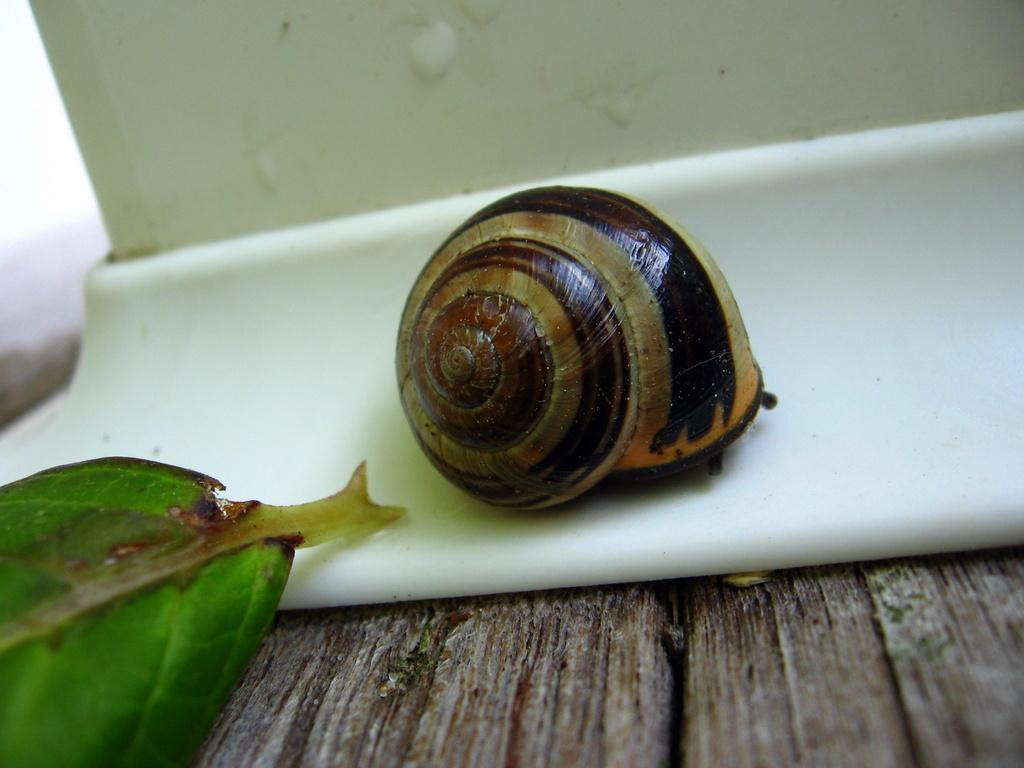What type of furniture is present in the image? There is a table in the image. What is located on the table? There is a snail and a leaf on the table. What type of peace agreement is being discussed at the meeting in the image? There is no meeting or peace agreement present in the image; it only features a table with a snail and a leaf. 